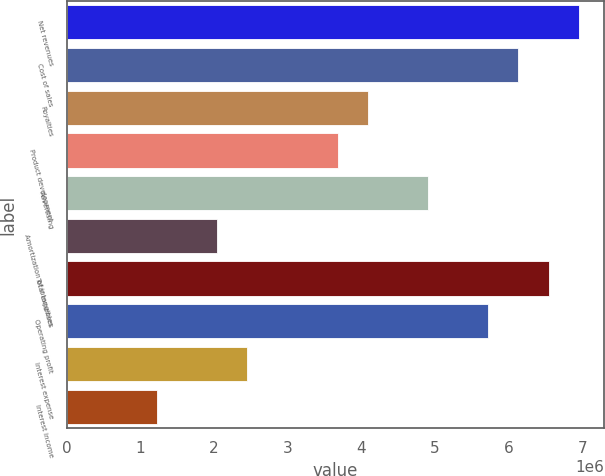Convert chart. <chart><loc_0><loc_0><loc_500><loc_500><bar_chart><fcel>Net revenues<fcel>Cost of sales<fcel>Royalties<fcel>Product development<fcel>Advertising<fcel>Amortization of intangibles<fcel>Total expenses<fcel>Operating profit<fcel>Interest expense<fcel>Interest income<nl><fcel>6.95127e+06<fcel>6.13347e+06<fcel>4.08898e+06<fcel>3.68008e+06<fcel>4.90678e+06<fcel>2.04449e+06<fcel>6.54237e+06<fcel>5.72458e+06<fcel>2.45339e+06<fcel>1.2267e+06<nl></chart> 